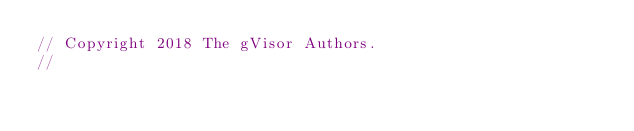Convert code to text. <code><loc_0><loc_0><loc_500><loc_500><_Go_>// Copyright 2018 The gVisor Authors.
//</code> 